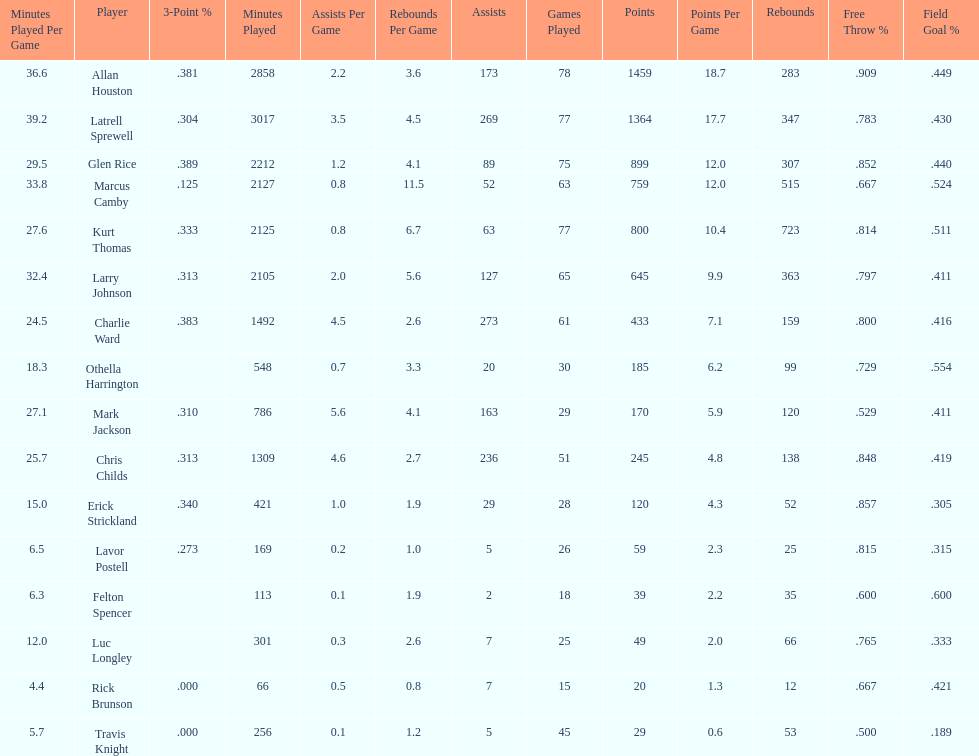How many games did larry johnson play? 65. 